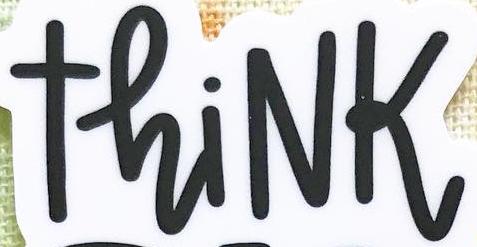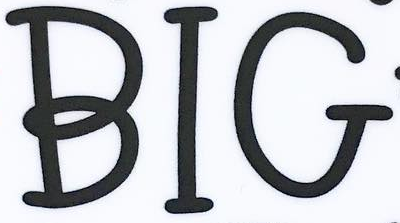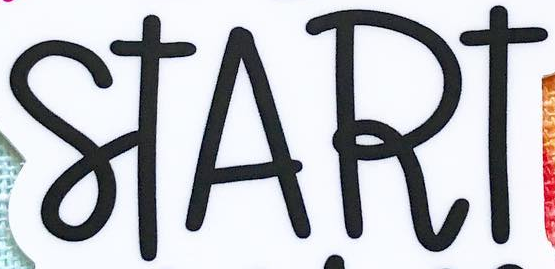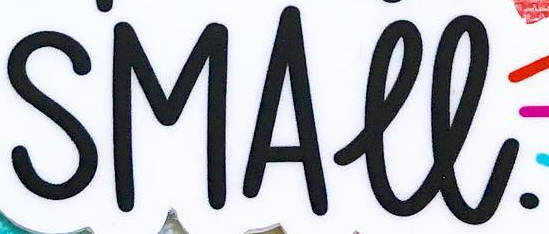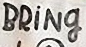Read the text content from these images in order, separated by a semicolon. ThiNK; BIG; START; SMALL.; BRİNg 